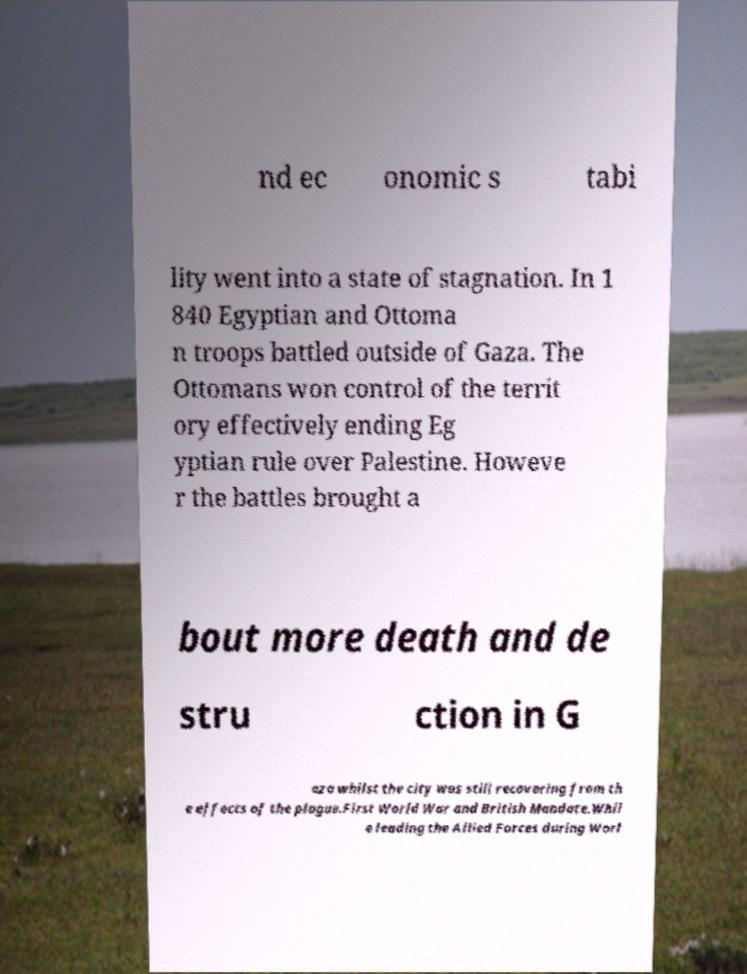Please identify and transcribe the text found in this image. nd ec onomic s tabi lity went into a state of stagnation. In 1 840 Egyptian and Ottoma n troops battled outside of Gaza. The Ottomans won control of the territ ory effectively ending Eg yptian rule over Palestine. Howeve r the battles brought a bout more death and de stru ction in G aza whilst the city was still recovering from th e effects of the plague.First World War and British Mandate.Whil e leading the Allied Forces during Worl 